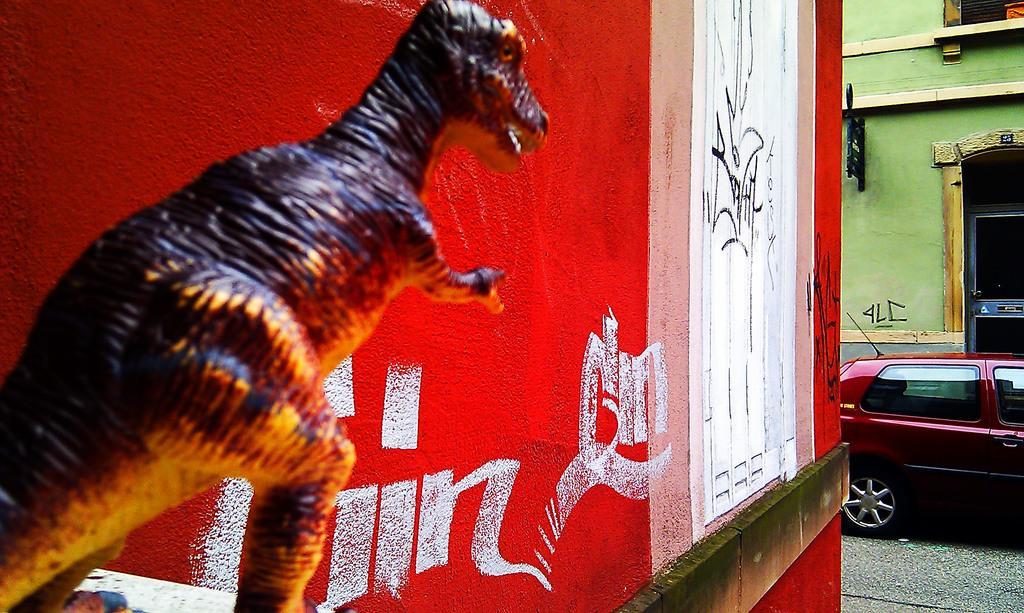How would you summarize this image in a sentence or two? On the left side of the image we can see a sculpture beside the red color wall, on the right side of the image we can find a building and a car on the road. 